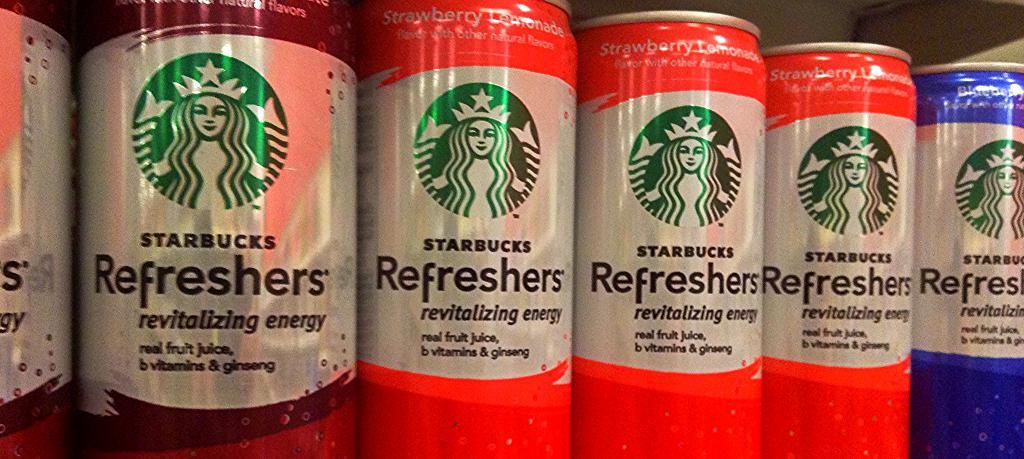<image>
Provide a brief description of the given image. Different flavors of Starbucks Refreshers are lined up next to each other. 